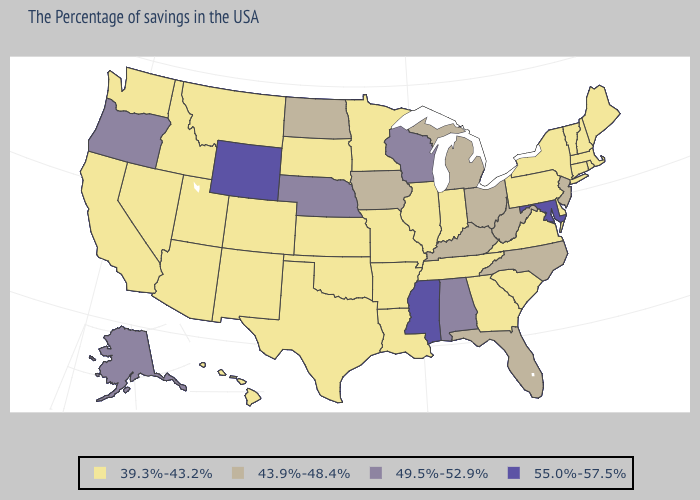What is the value of Montana?
Be succinct. 39.3%-43.2%. Among the states that border Illinois , which have the highest value?
Be succinct. Wisconsin. Which states have the lowest value in the USA?
Quick response, please. Maine, Massachusetts, Rhode Island, New Hampshire, Vermont, Connecticut, New York, Delaware, Pennsylvania, Virginia, South Carolina, Georgia, Indiana, Tennessee, Illinois, Louisiana, Missouri, Arkansas, Minnesota, Kansas, Oklahoma, Texas, South Dakota, Colorado, New Mexico, Utah, Montana, Arizona, Idaho, Nevada, California, Washington, Hawaii. Is the legend a continuous bar?
Write a very short answer. No. Does the map have missing data?
Short answer required. No. Which states have the highest value in the USA?
Write a very short answer. Maryland, Mississippi, Wyoming. Name the states that have a value in the range 55.0%-57.5%?
Be succinct. Maryland, Mississippi, Wyoming. Among the states that border Missouri , does Oklahoma have the lowest value?
Keep it brief. Yes. What is the lowest value in the USA?
Concise answer only. 39.3%-43.2%. Among the states that border Maryland , does Virginia have the highest value?
Short answer required. No. Among the states that border Massachusetts , which have the lowest value?
Concise answer only. Rhode Island, New Hampshire, Vermont, Connecticut, New York. What is the value of Wyoming?
Write a very short answer. 55.0%-57.5%. Does Louisiana have a lower value than New Mexico?
Keep it brief. No. Does Alabama have the lowest value in the USA?
Be succinct. No. What is the value of Tennessee?
Short answer required. 39.3%-43.2%. 